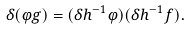<formula> <loc_0><loc_0><loc_500><loc_500>\delta ( \varphi g ) = ( \delta h ^ { - 1 } \varphi ) ( \delta h ^ { - 1 } f ) .</formula> 